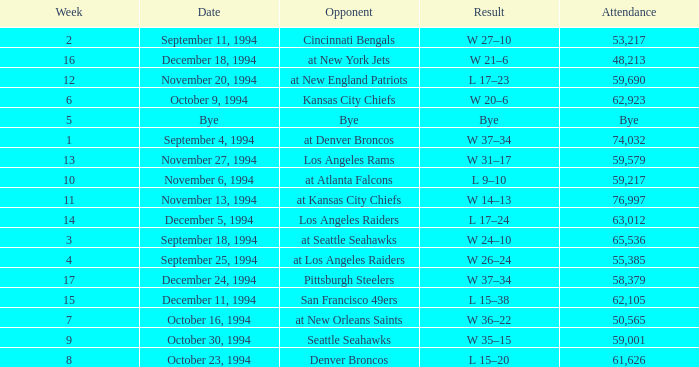In the game on or before week 9, who was the opponent when the attendance was 61,626? Denver Broncos. 